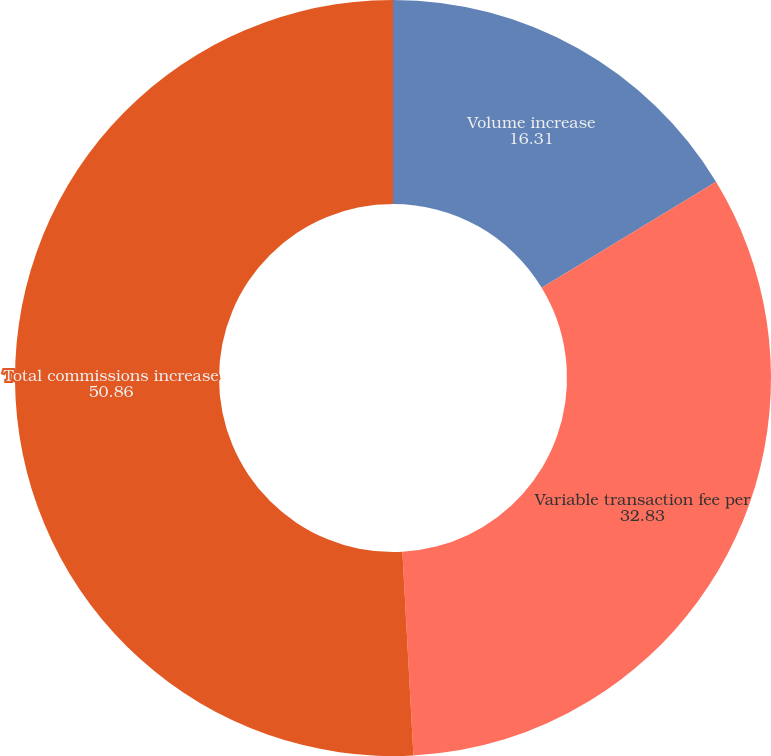Convert chart to OTSL. <chart><loc_0><loc_0><loc_500><loc_500><pie_chart><fcel>Volume increase<fcel>Variable transaction fee per<fcel>Total commissions increase<nl><fcel>16.31%<fcel>32.83%<fcel>50.86%<nl></chart> 